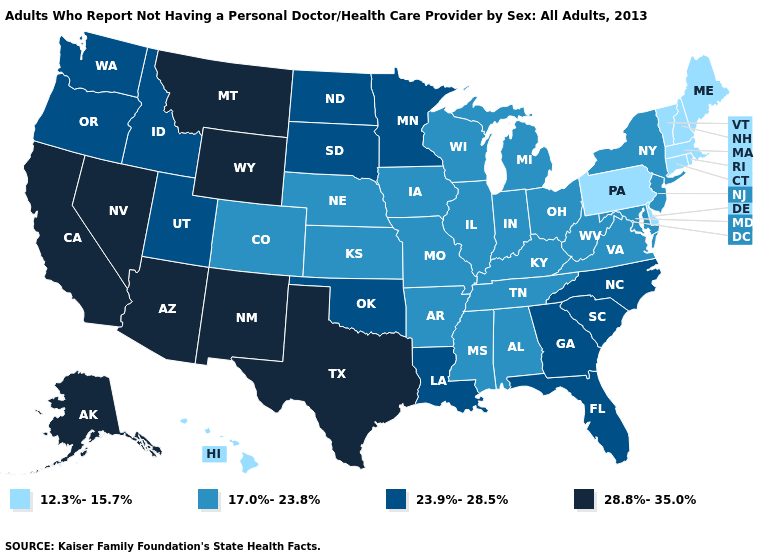Which states have the lowest value in the USA?
Be succinct. Connecticut, Delaware, Hawaii, Maine, Massachusetts, New Hampshire, Pennsylvania, Rhode Island, Vermont. What is the value of North Dakota?
Give a very brief answer. 23.9%-28.5%. What is the value of Montana?
Give a very brief answer. 28.8%-35.0%. Does the first symbol in the legend represent the smallest category?
Short answer required. Yes. Name the states that have a value in the range 28.8%-35.0%?
Give a very brief answer. Alaska, Arizona, California, Montana, Nevada, New Mexico, Texas, Wyoming. How many symbols are there in the legend?
Quick response, please. 4. What is the value of Rhode Island?
Quick response, please. 12.3%-15.7%. Does the first symbol in the legend represent the smallest category?
Write a very short answer. Yes. Which states hav the highest value in the West?
Write a very short answer. Alaska, Arizona, California, Montana, Nevada, New Mexico, Wyoming. What is the value of Ohio?
Answer briefly. 17.0%-23.8%. Name the states that have a value in the range 28.8%-35.0%?
Give a very brief answer. Alaska, Arizona, California, Montana, Nevada, New Mexico, Texas, Wyoming. What is the value of Illinois?
Concise answer only. 17.0%-23.8%. Does Washington have a lower value than Texas?
Quick response, please. Yes. Name the states that have a value in the range 23.9%-28.5%?
Concise answer only. Florida, Georgia, Idaho, Louisiana, Minnesota, North Carolina, North Dakota, Oklahoma, Oregon, South Carolina, South Dakota, Utah, Washington. 